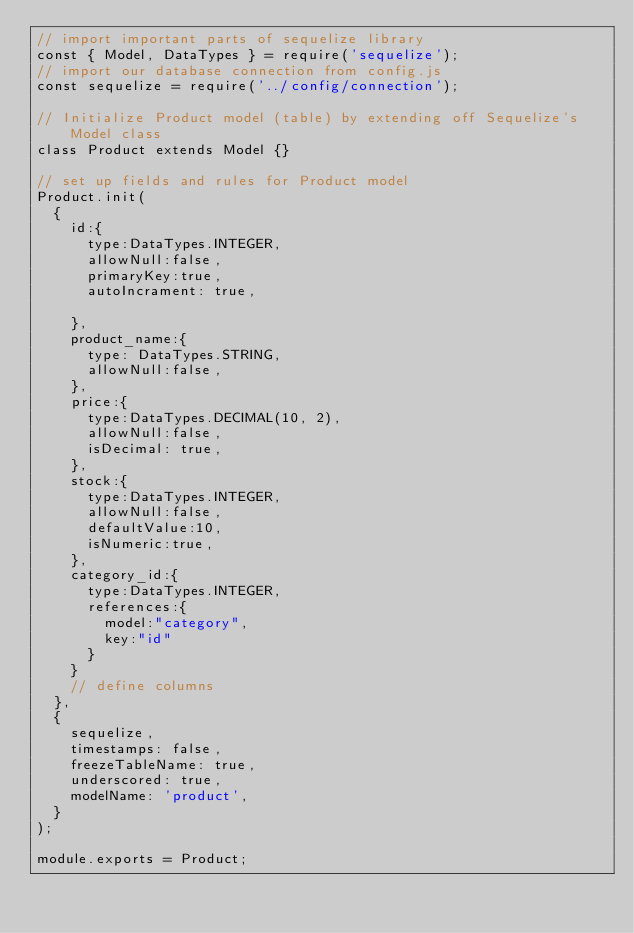<code> <loc_0><loc_0><loc_500><loc_500><_JavaScript_>// import important parts of sequelize library
const { Model, DataTypes } = require('sequelize');
// import our database connection from config.js
const sequelize = require('../config/connection');

// Initialize Product model (table) by extending off Sequelize's Model class
class Product extends Model {}

// set up fields and rules for Product model
Product.init(
  {
    id:{
      type:DataTypes.INTEGER,
      allowNull:false,
      primaryKey:true,
      autoIncrament: true,

    },
    product_name:{
      type: DataTypes.STRING,
      allowNull:false,
    },
    price:{
      type:DataTypes.DECIMAL(10, 2),
      allowNull:false,
      isDecimal: true,
    },
    stock:{
      type:DataTypes.INTEGER,
      allowNull:false,
      defaultValue:10,
      isNumeric:true,
    },
    category_id:{
      type:DataTypes.INTEGER,
      references:{
        model:"category",
        key:"id"
      }
    }
    // define columns
  },
  {
    sequelize,
    timestamps: false,
    freezeTableName: true,
    underscored: true,
    modelName: 'product',
  }
);

module.exports = Product;
</code> 